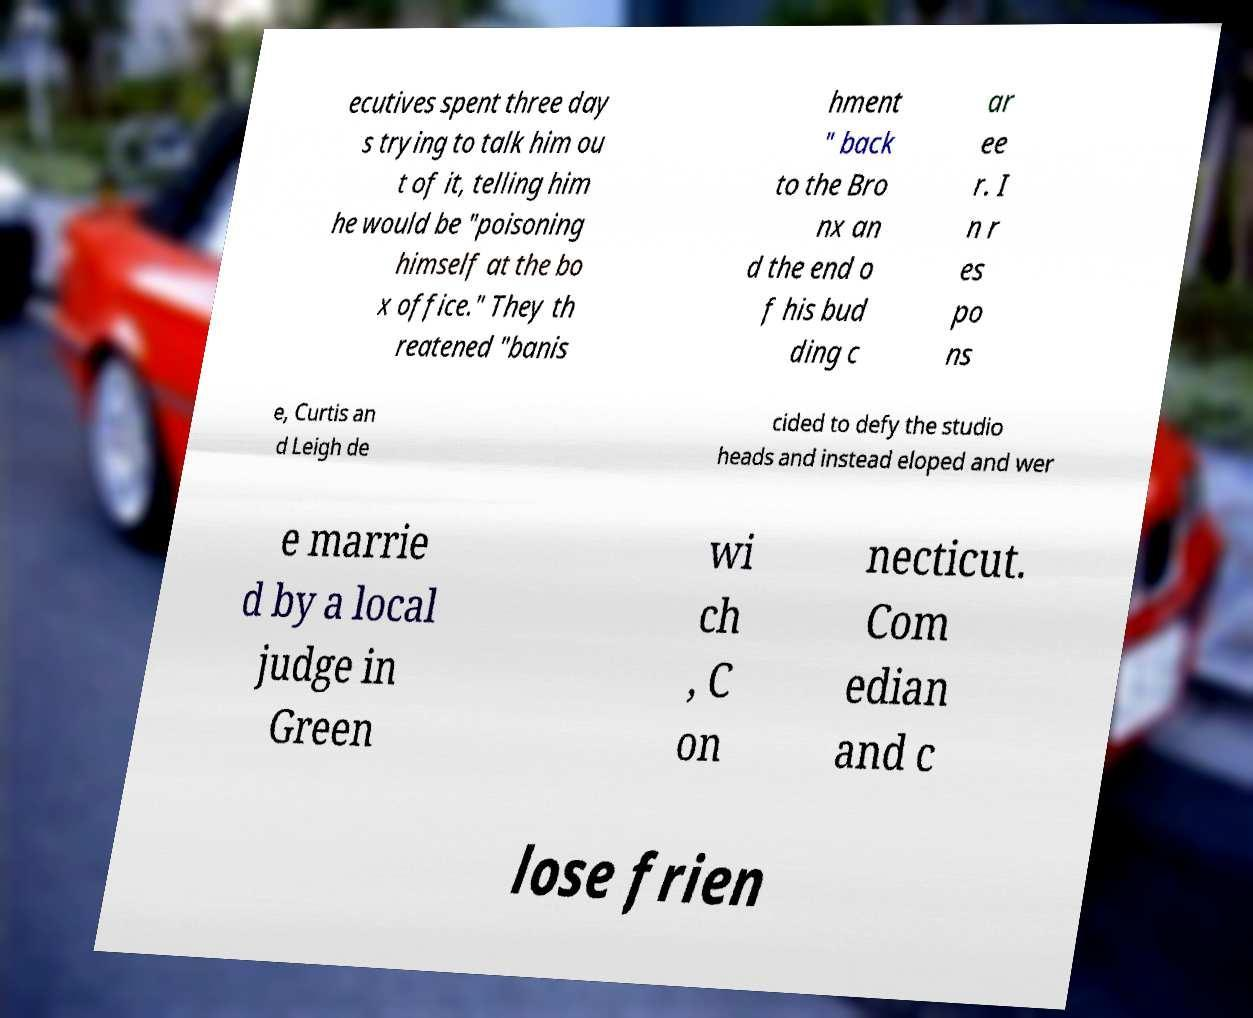There's text embedded in this image that I need extracted. Can you transcribe it verbatim? ecutives spent three day s trying to talk him ou t of it, telling him he would be "poisoning himself at the bo x office." They th reatened "banis hment " back to the Bro nx an d the end o f his bud ding c ar ee r. I n r es po ns e, Curtis an d Leigh de cided to defy the studio heads and instead eloped and wer e marrie d by a local judge in Green wi ch , C on necticut. Com edian and c lose frien 